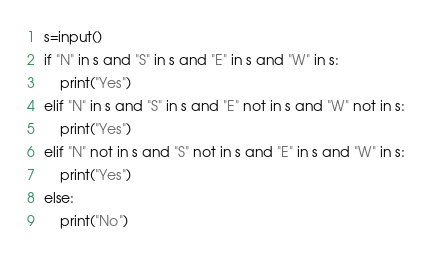Convert code to text. <code><loc_0><loc_0><loc_500><loc_500><_Python_>s=input()
if "N" in s and "S" in s and "E" in s and "W" in s:
    print("Yes")
elif "N" in s and "S" in s and "E" not in s and "W" not in s:
    print("Yes")
elif "N" not in s and "S" not in s and "E" in s and "W" in s:
    print("Yes")
else:
    print("No")</code> 